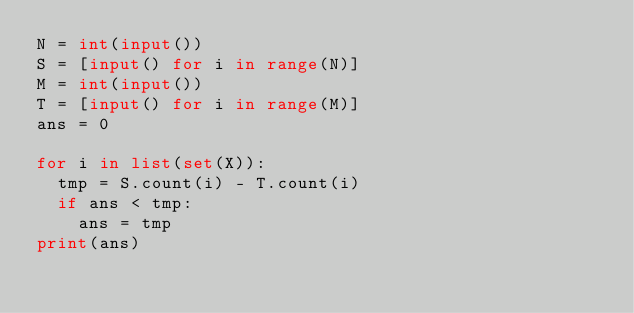<code> <loc_0><loc_0><loc_500><loc_500><_Python_>N = int(input())
S = [input() for i in range(N)]
M = int(input())
T = [input() for i in range(M)]
ans = 0

for i in list(set(X)):
  tmp = S.count(i) - T.count(i)
  if ans < tmp:
    ans = tmp
print(ans)</code> 